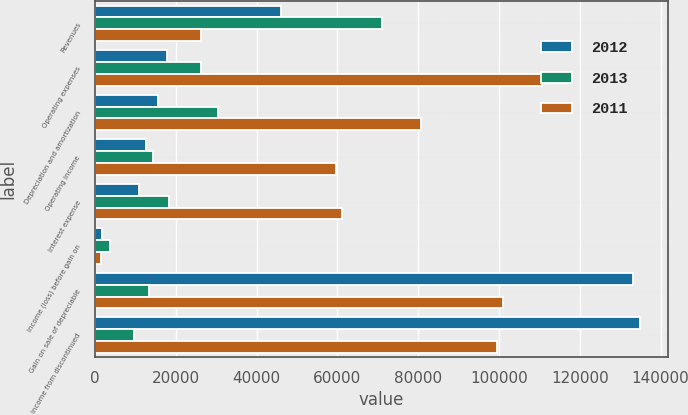<chart> <loc_0><loc_0><loc_500><loc_500><stacked_bar_chart><ecel><fcel>Revenues<fcel>Operating expenses<fcel>Depreciation and amortization<fcel>Operating income<fcel>Interest expense<fcel>Income (loss) before gain on<fcel>Gain on sale of depreciable<fcel>Income from discontinued<nl><fcel>2012<fcel>46066<fcel>17777<fcel>15600<fcel>12689<fcel>10928<fcel>1761<fcel>133242<fcel>135003<nl><fcel>2013<fcel>71028<fcel>26139<fcel>30404<fcel>14485<fcel>18271<fcel>3786<fcel>13467<fcel>9681<nl><fcel>2011<fcel>26139<fcel>110634<fcel>80609<fcel>59564<fcel>61041<fcel>1477<fcel>100882<fcel>99405<nl></chart> 